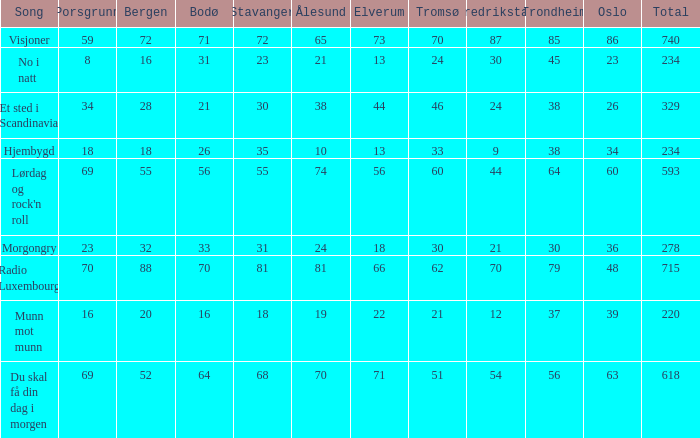Write the full table. {'header': ['Song', 'Porsgrunn', 'Bergen', 'Bodø', 'Stavanger', 'Ålesund', 'Elverum', 'Tromsø', 'Fredrikstad', 'Trondheim', 'Oslo', 'Total'], 'rows': [['Visjoner', '59', '72', '71', '72', '65', '73', '70', '87', '85', '86', '740'], ['No i natt', '8', '16', '31', '23', '21', '13', '24', '30', '45', '23', '234'], ['Et sted i Scandinavia', '34', '28', '21', '30', '38', '44', '46', '24', '38', '26', '329'], ['Hjembygd', '18', '18', '26', '35', '10', '13', '33', '9', '38', '34', '234'], ["Lørdag og rock'n roll", '69', '55', '56', '55', '74', '56', '60', '44', '64', '60', '593'], ['Morgongry', '23', '32', '33', '31', '24', '18', '30', '21', '30', '36', '278'], ['Radio Luxembourg', '70', '88', '70', '81', '81', '66', '62', '70', '79', '48', '715'], ['Munn mot munn', '16', '20', '16', '18', '19', '22', '21', '12', '37', '39', '220'], ['Du skal få din dag i morgen', '69', '52', '64', '68', '70', '71', '51', '54', '56', '63', '618']]} When the number for oslo is 48, what number corresponds to stavanger? 81.0. 